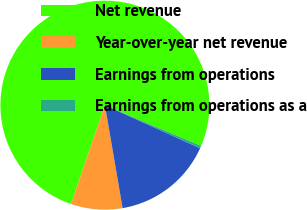Convert chart. <chart><loc_0><loc_0><loc_500><loc_500><pie_chart><fcel>Net revenue<fcel>Year-over-year net revenue<fcel>Earnings from operations<fcel>Earnings from operations as a<nl><fcel>76.13%<fcel>7.96%<fcel>15.53%<fcel>0.38%<nl></chart> 